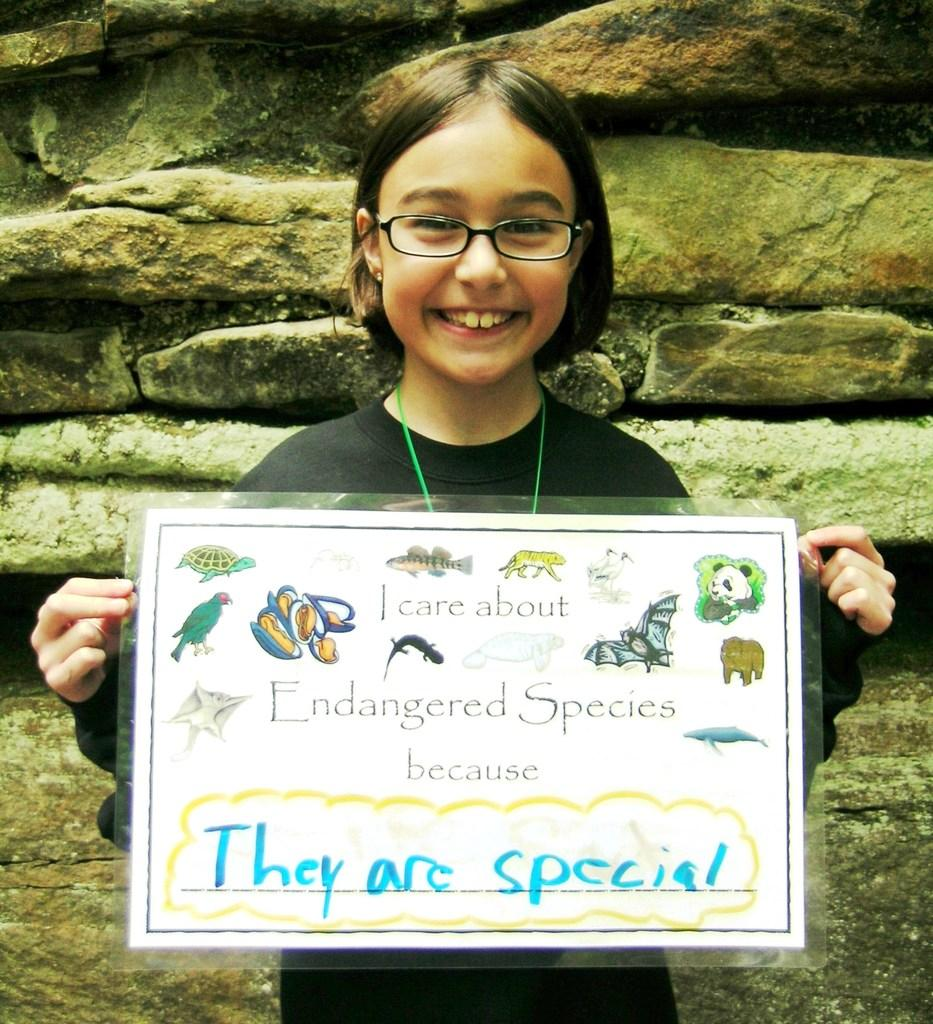Who is the main subject in the image? There is a girl in the image. What is the girl wearing? The girl is wearing spectacles. What is the girl's facial expression? The girl is smiling. What is the girl holding in the image? The girl is holding a laminated paper. What can be seen in the background of the image? There are rocks in the background of the image. What is the girl arguing about with the nut in the image? There is no nut present in the image, and the girl is not engaged in an argument. 